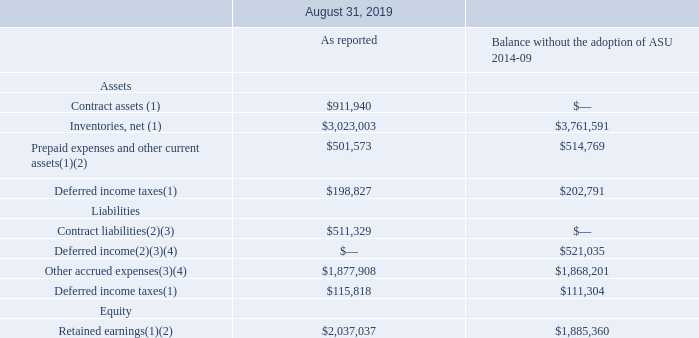18. Revenue
Effective September 1, 2018, the Company adopted ASU 2014-09, Revenue Recognition (Topic 606). The new standard is a comprehensive new revenue recognition model that requires the Company to recognize revenue in a manner which depicts the transfer of goods or services to its customers at an amount that reflects the consideration the Company expects to receive in exchange for those goods or services.
Prior to the adoption of the new standard, the Company recognized substantially all of its revenue from contracts with customers at a point in time, which was generally when the goods were shipped to or received by the customer, title and risk of ownership had passed, the price to the buyer was fixed or determinable and collectability was reasonably assured (net of estimated returns). Under the new standard, the Company recognizes revenue over time for the majority of its contracts with customers which results in revenue for those customers being recognized earlier than under the previous guidance. Revenue for all other contracts with customers continues to be recognized at a point in time, similar to recognition prior to the adoption of the standard.
Additionally, the new standard impacts the Company’s accounting for certain fulfillment costs, which include upfront costs to prepare for manufacturing activities that are expected to be recovered. Under the new standard, such upfront costs are recognized as an asset and amortized on a systematic basis consistent with the pattern of the transfer of control of the products or services to which to the asset relates.
The following table presents the effect of the adoption of the new revenue guidance on the Consolidated Balance Sheets as of August 31, 2019 (in thousands):
(1) Differences primarily relate to the timing of revenue recognition for over time customers and certain balance sheet reclassifications.
(2) Differences primarily relate to the timing of recognition and recovery of fulfillment costs and certain balance sheet reclassifications.
(3) Included within accrued expenses on the Consolidated Balance Sheets.
(4) Differences included in contract liabilities as of September 1, 2018.
What do the differences in contract assets primarily relate to? The timing of revenue recognition for over time customers and certain balance sheet reclassifications. What were the net inventories as reported?
Answer scale should be: thousand. $3,023,003. What were the contract liabilities as reported?
Answer scale should be: thousand. $511,329. What was the change in Inventories, net due to adoption of ASU 2014-09?
Answer scale should be: thousand. 3,023,003-3,761,591
Answer: -738588. What was the change in Prepaid expenses and other current assets due to the adoption of ASU 2014-09?
Answer scale should be: thousand. 501,573-514,769
Answer: -13196. How many segments as reported exceed $2,000,000 thousand? Inventories, net##Retained earnings
Answer: 2. 